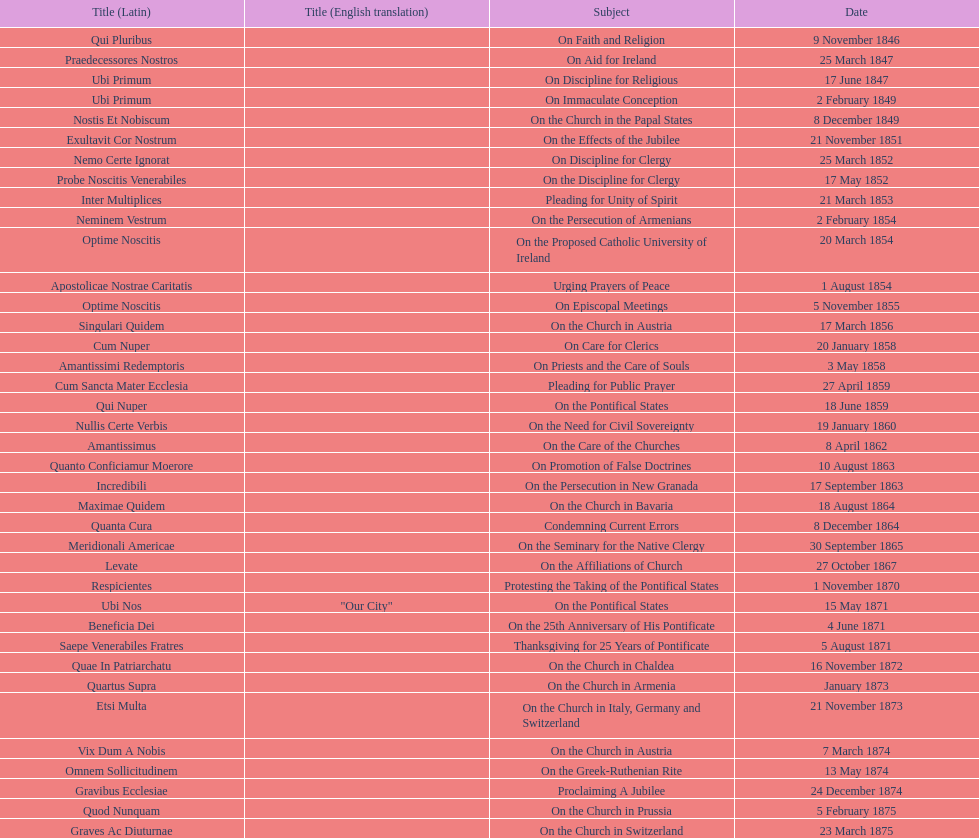What is the last title? Graves Ac Diuturnae. 